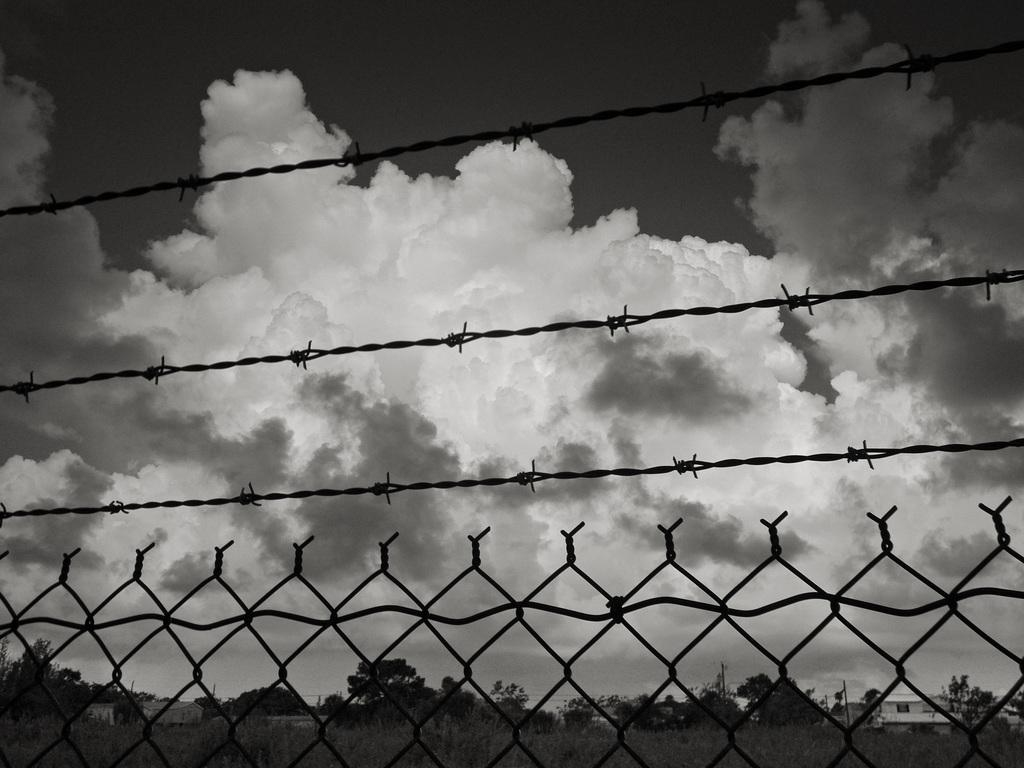What type of structure can be seen in the image? There is fencing in the image. What else is present in the image besides the fencing? There are ropes visible in the image. What can be seen in the background of the image? There are trees and houses in the background of the image. How would you describe the sky in the image? The sky is cloudy at the top of the image. What type of joke is being told by the coach in the image? There is no coach or joke present in the image. What type of operation is being performed on the trees in the image? There is no operation being performed on the trees in the image; they are simply visible in the background. 